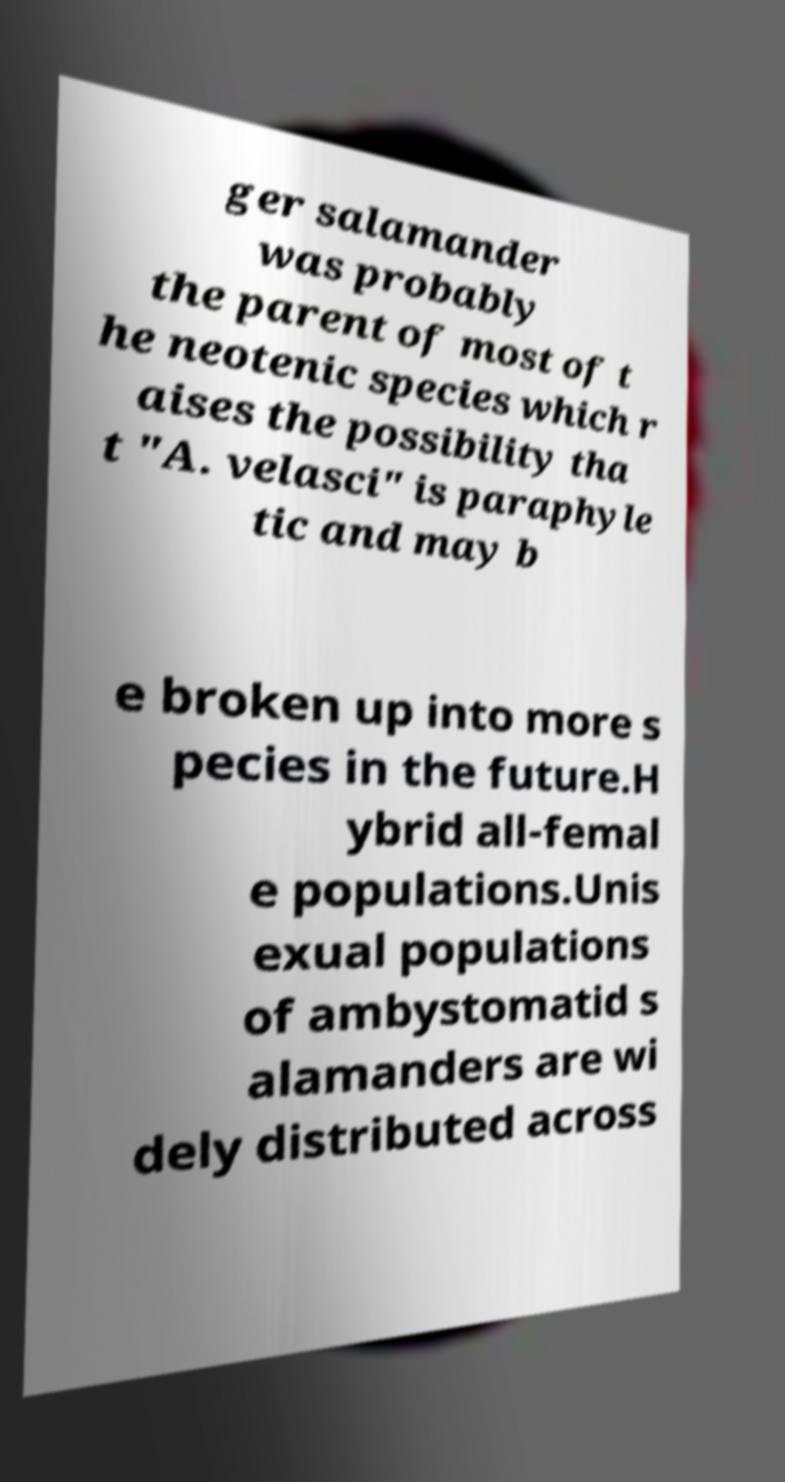For documentation purposes, I need the text within this image transcribed. Could you provide that? ger salamander was probably the parent of most of t he neotenic species which r aises the possibility tha t "A. velasci" is paraphyle tic and may b e broken up into more s pecies in the future.H ybrid all-femal e populations.Unis exual populations of ambystomatid s alamanders are wi dely distributed across 